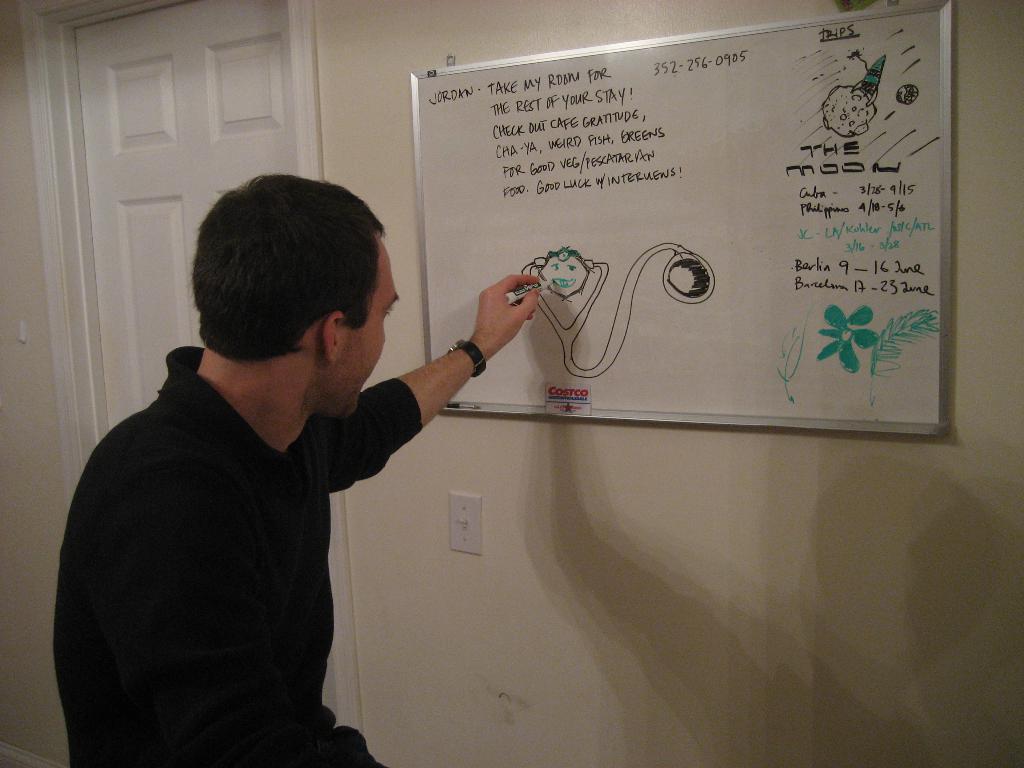What is pictured in the top right corner of the whiteboard?
Your answer should be compact. Answering does not require reading text in the image. What phone number is written on the board?
Make the answer very short. 352-256-0905. 